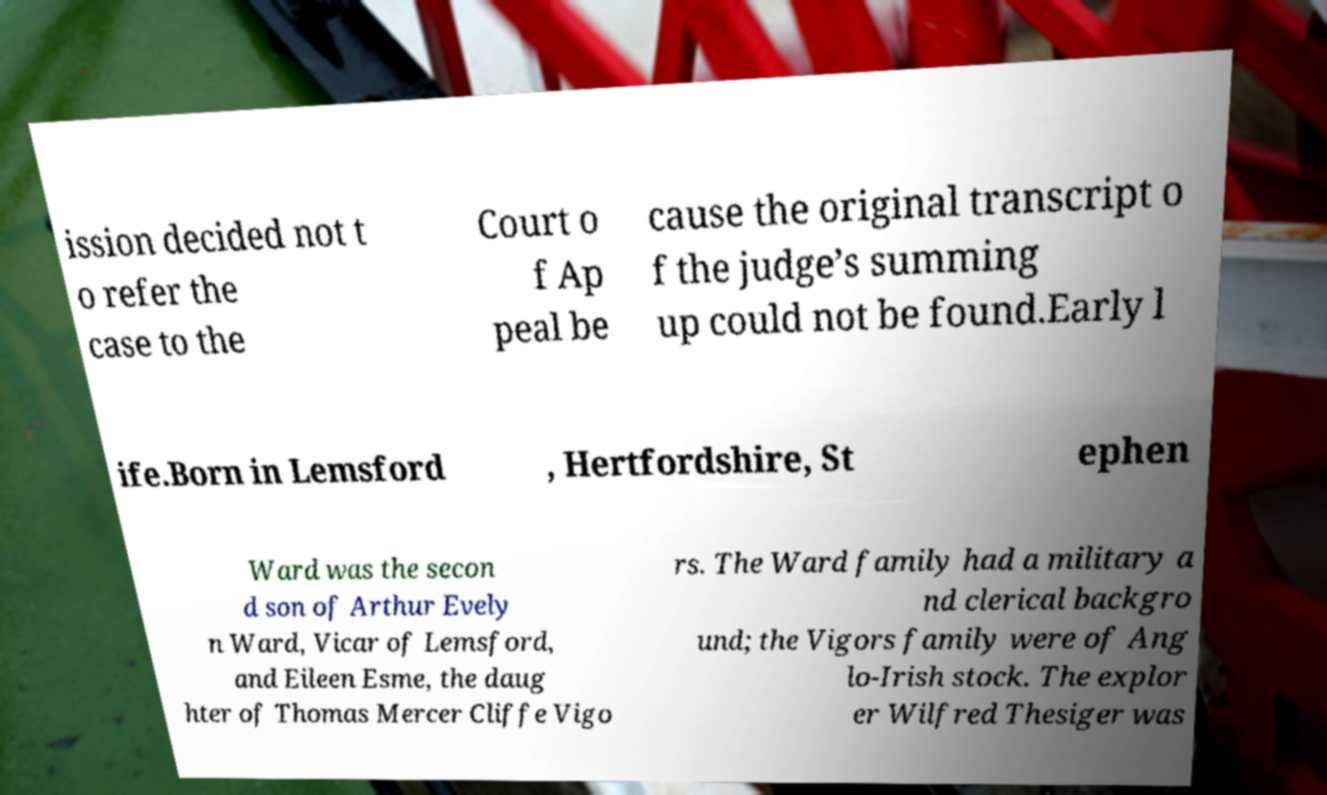Please identify and transcribe the text found in this image. ission decided not t o refer the case to the Court o f Ap peal be cause the original transcript o f the judge’s summing up could not be found.Early l ife.Born in Lemsford , Hertfordshire, St ephen Ward was the secon d son of Arthur Evely n Ward, Vicar of Lemsford, and Eileen Esme, the daug hter of Thomas Mercer Cliffe Vigo rs. The Ward family had a military a nd clerical backgro und; the Vigors family were of Ang lo-Irish stock. The explor er Wilfred Thesiger was 